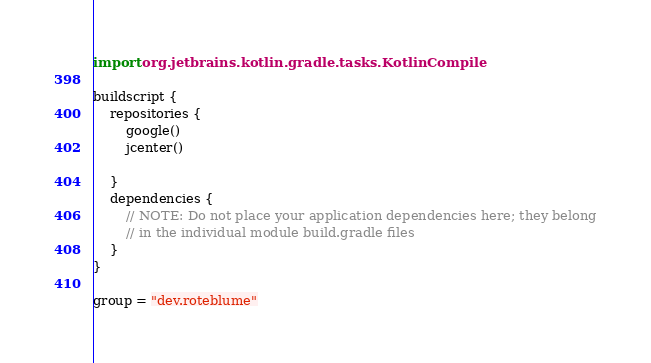Convert code to text. <code><loc_0><loc_0><loc_500><loc_500><_Kotlin_>import org.jetbrains.kotlin.gradle.tasks.KotlinCompile

buildscript {
    repositories {
        google()
        jcenter()

    }
    dependencies {
        // NOTE: Do not place your application dependencies here; they belong
        // in the individual module build.gradle files
    }
}

group = "dev.roteblume"
</code> 